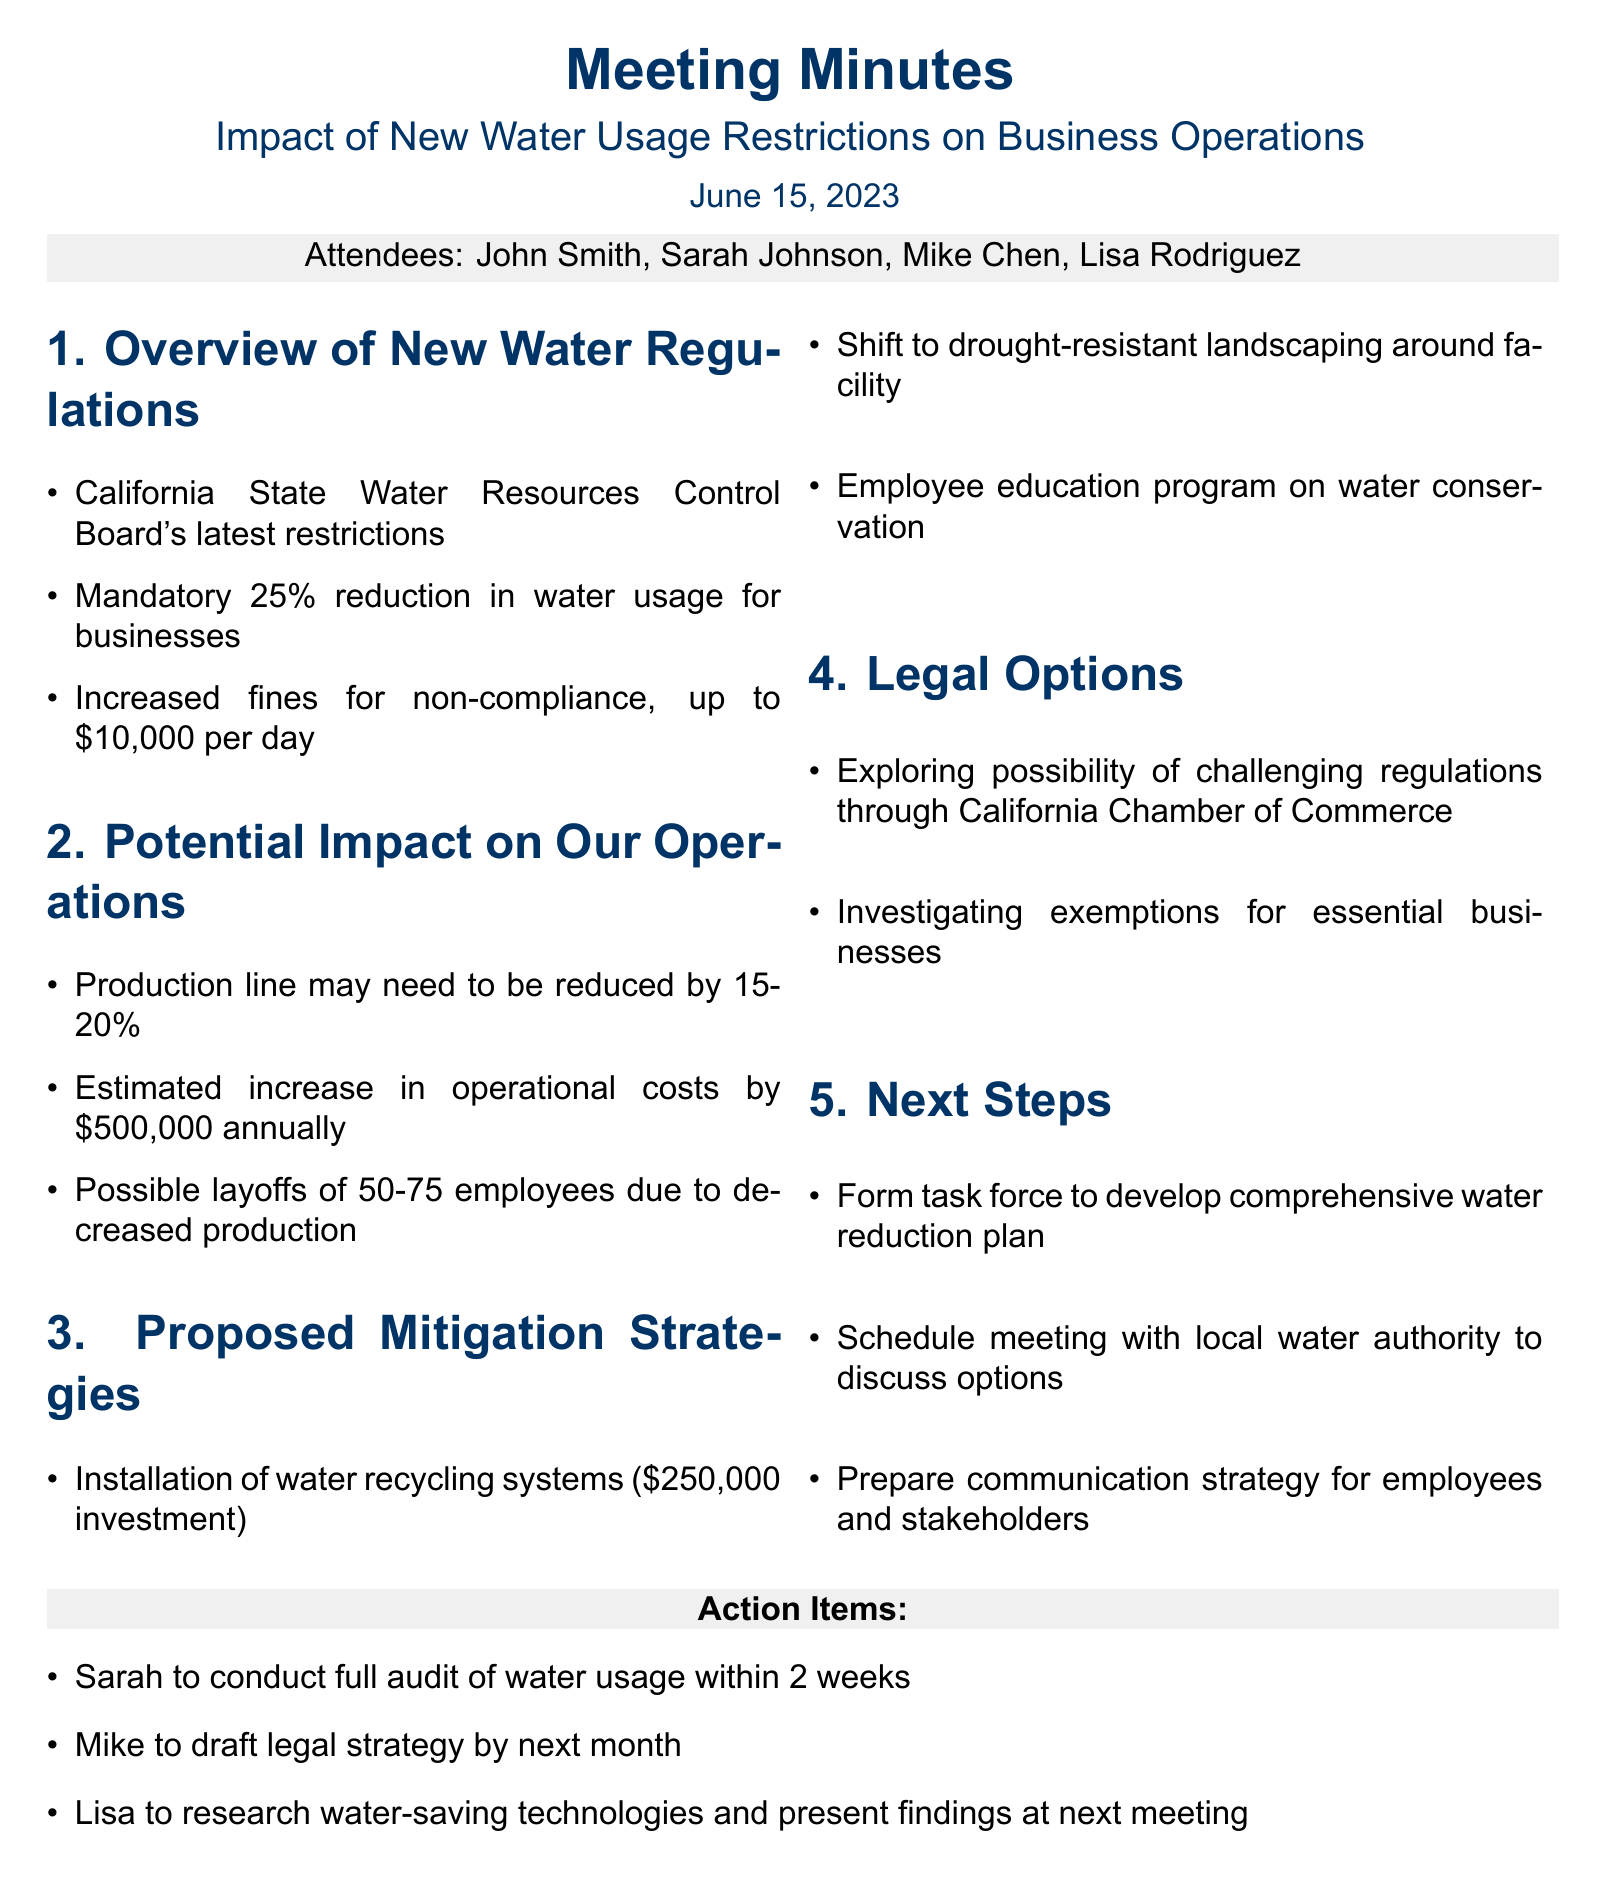What is the date of the meeting? The date of the meeting is mentioned at the beginning of the document.
Answer: June 15, 2023 Who is the Head of Operations? The names and titles of attendees are listed, including the Head of Operations.
Answer: Sarah Johnson What is the mandatory reduction percentage in water usage for businesses? The document states the specific percentage that businesses must reduce their water usage.
Answer: 25% What is the estimated annual increase in operational costs? The document provides an estimate for the additional annual costs attributed to the new regulations.
Answer: $500,000 How many employees might be laid off due to decreased production? The potential layoffs are listed in the potential impact section.
Answer: 50-75 What is one proposed mitigation strategy discussed? The proposed mitigation strategies section contains suggested actions to adapt to restrictions.
Answer: Installation of water recycling systems Which organization is mentioned regarding legal options? The legal options section includes an organization that may assist in challenging regulations.
Answer: California Chamber of Commerce What will Sarah conduct within two weeks as an action item? The action items list specifies what Sarah is tasked to accomplish in the near term.
Answer: Full audit of water usage 